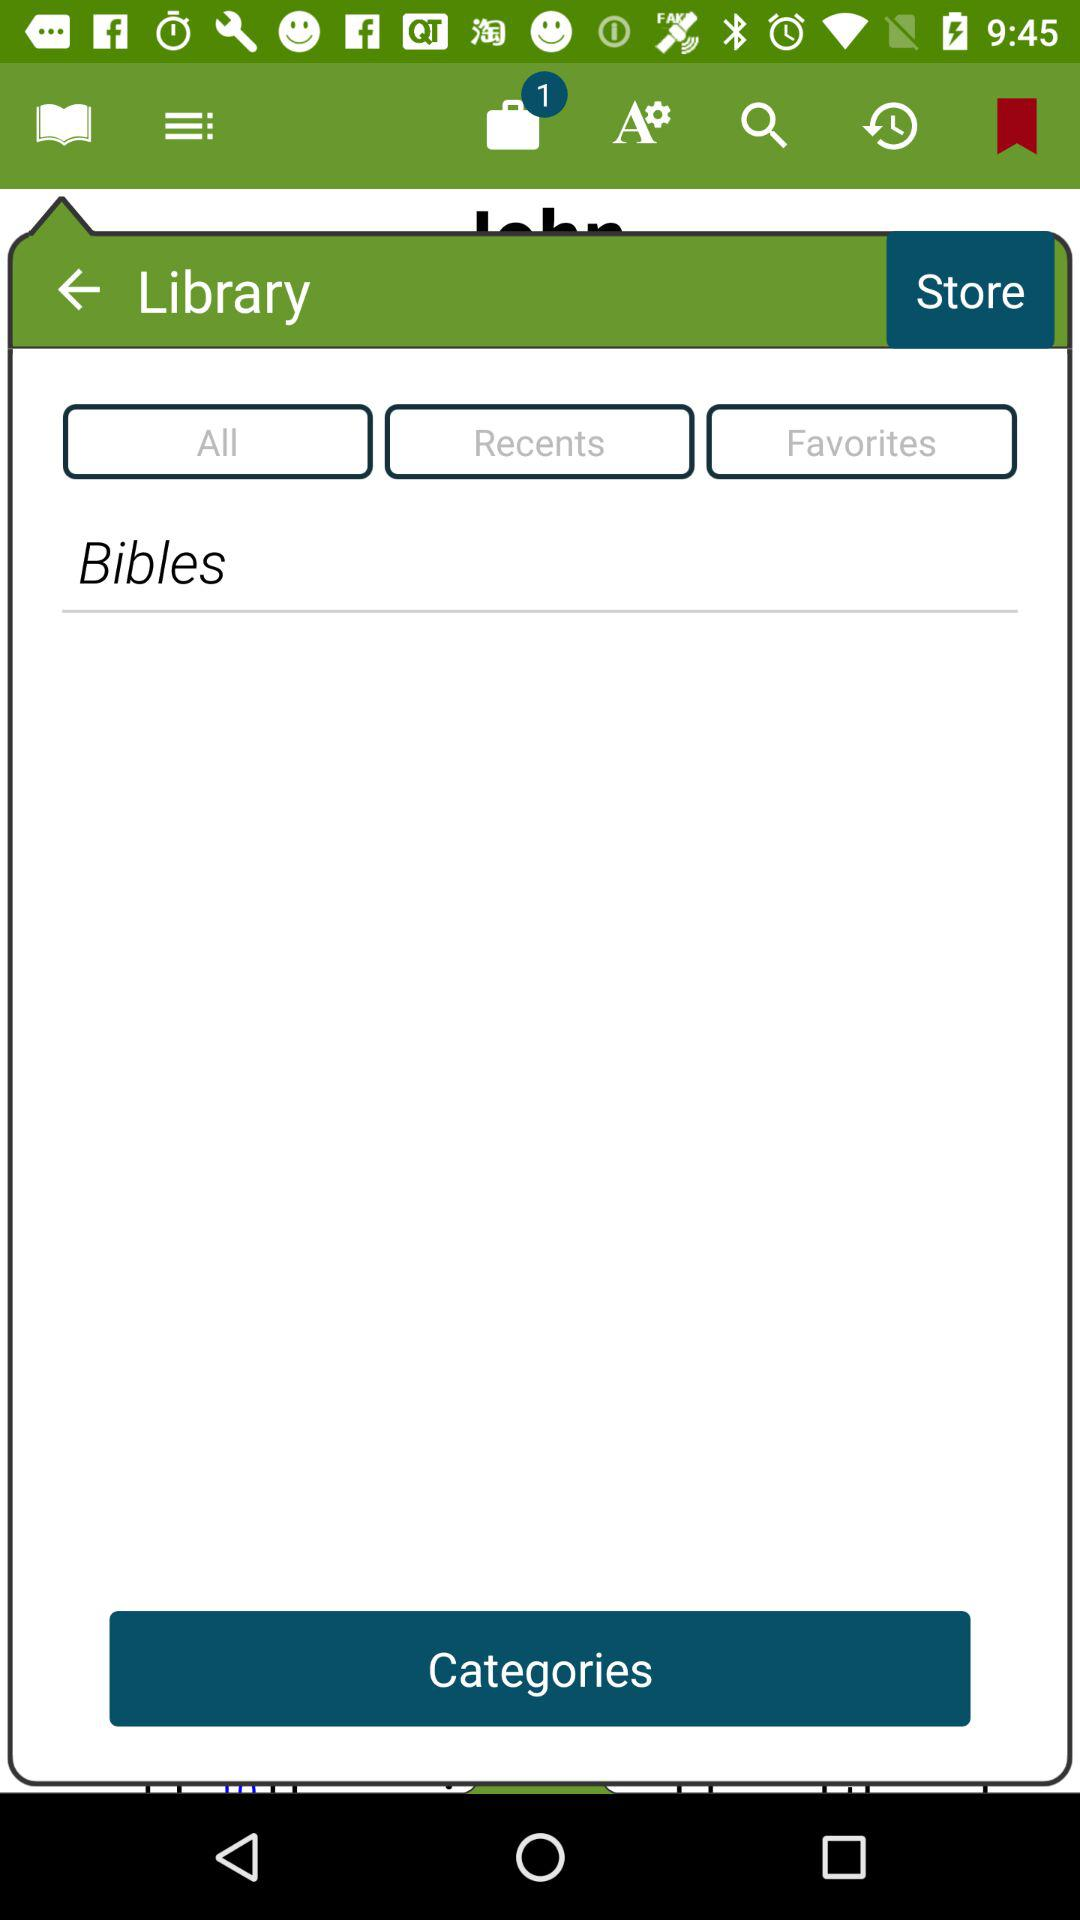How many text inputs are on the screen?
Answer the question using a single word or phrase. 1 